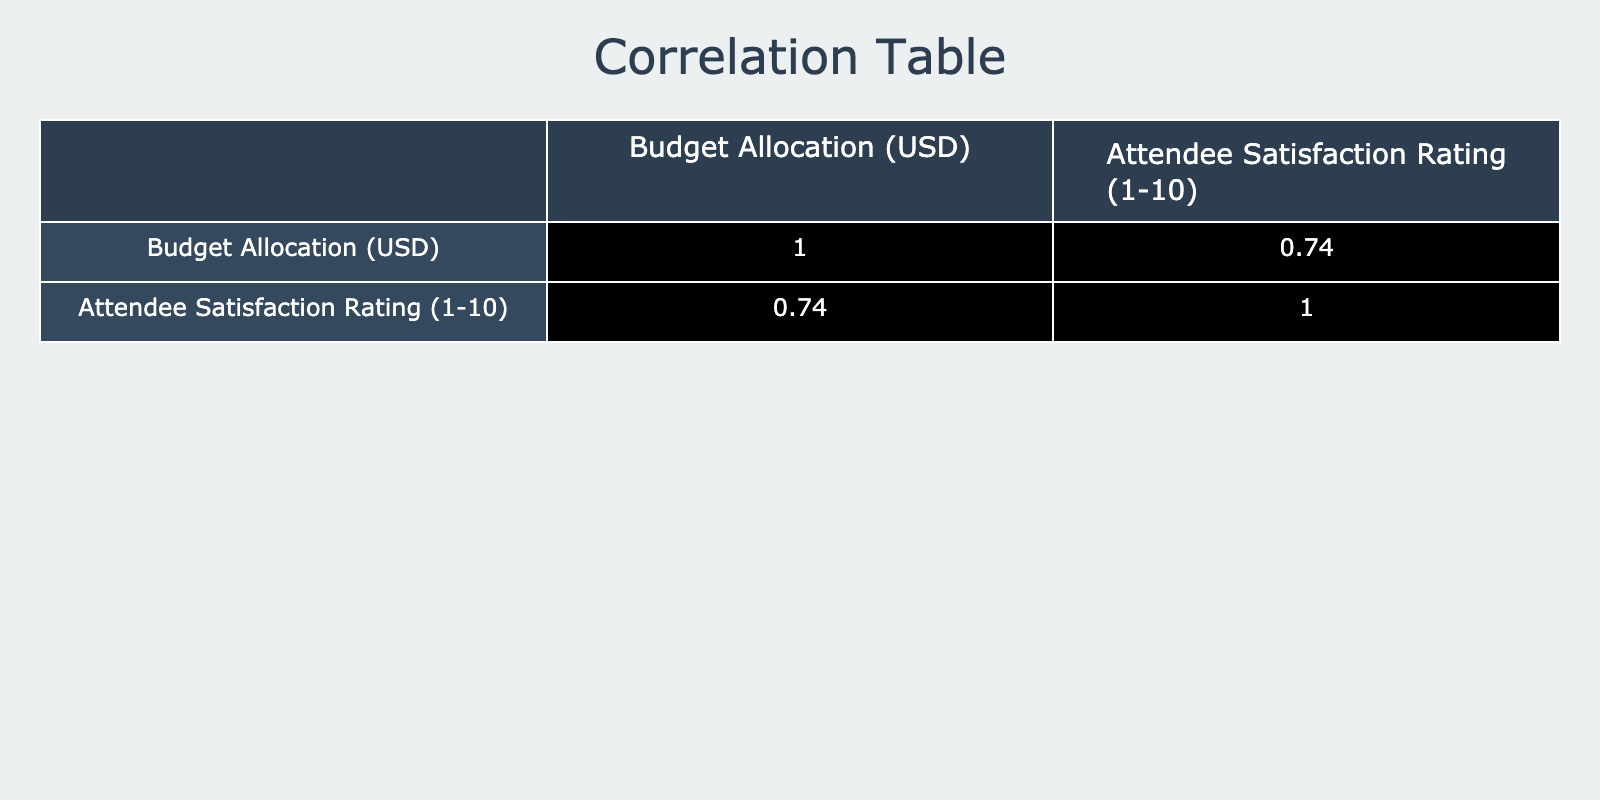What is the budget allocation for the Filmmaker Forum 2023? The table shows the budget allocation for each event. For the Filmmaker Forum 2023, the budget listed is 30000 USD.
Answer: 30000 USD What is the attendee satisfaction rating for the Short Film Society Gala? Referring to the table, the attendee satisfaction rating for the Short Film Society Gala is stated as 7.
Answer: 7 Which event had the highest budget allocation and what was that amount? By examining the budget allocations in the table, the event with the highest allocation is the Filmmaker Forum 2023, which had a budget of 30000 USD.
Answer: 30000 USD Is it true that events with a budget allocation of more than 20000 USD generally received higher satisfaction ratings? The table lists events with budget allocations above 20000 USD, such as Indie Film Fest 2023 (8), Filmmaker Forum 2023 (9), Next Gen Film Network (8), and Emerging Voices Festival (8). Since all these events have ratings greater than or equal to 7, the statement holds true.
Answer: Yes What is the average satisfaction rating of events that had a budget allocation of 20000 USD or more? The events with budget allocation of 20000 USD or more are: Filmmaker Forum (9), Indie Film Fest (8), Next Gen Film Network (8), Emerging Voices Festival (8), and Documentary Showcase (7). Calculating the average: (9 + 8 + 8 + 8 + 7) = 40, then dividing by the number of events (5), gives the average satisfaction rating of 8.
Answer: 8 What is the lowest satisfaction rating among all the events? Looking through the satisfaction ratings in the table, the lowest rating recorded is 5, which corresponds to the Reel Talk Networking Night.
Answer: 5 How many events had satisfaction ratings below 7? Scanning the table for ratings below 7, we find that there are two events: Script to Screen (6) and Reel Talk Networking Night (5). Therefore, there are 2 events with ratings below 7.
Answer: 2 What is the difference in satisfaction ratings between the highest rated event and the lowest rated event? The highest rated event is the Filmmaker Forum 2023 with a rating of 9, and the lowest is Reel Talk Networking Night with a rating of 5. Therefore, the difference in ratings is 9 - 5 = 4.
Answer: 4 Are there any events with a budget allocation of exactly 20000 USD? Reviewing the budget allocations in the table, the only event with a budget exactly at 20000 USD is Script to Screen 2023. Therefore, the answer is true.
Answer: Yes 